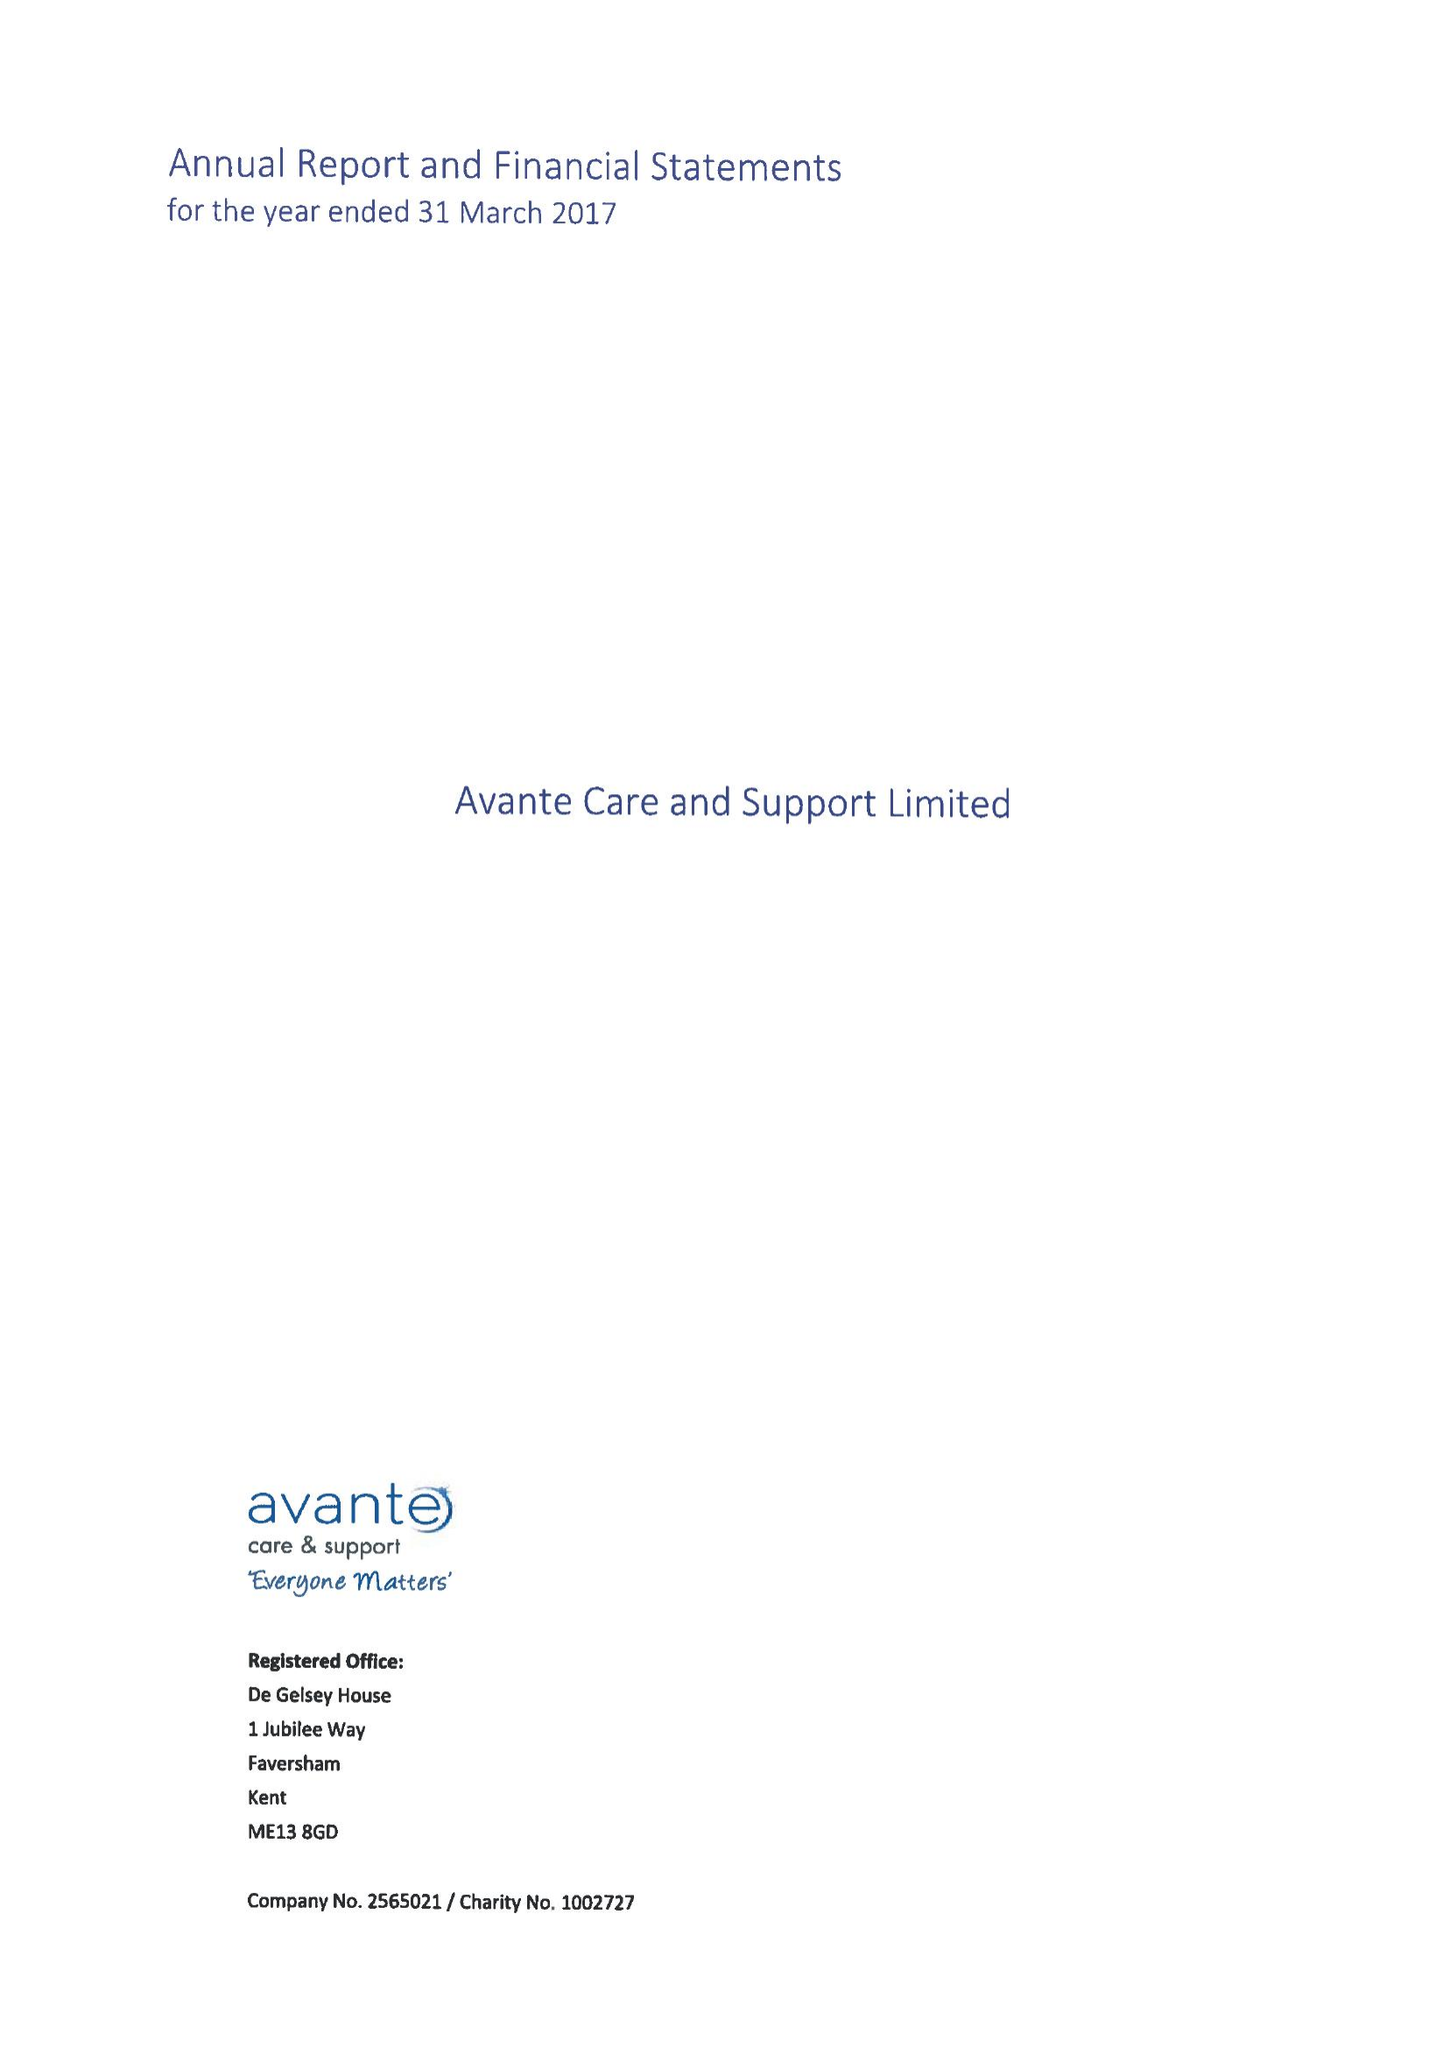What is the value for the income_annually_in_british_pounds?
Answer the question using a single word or phrase. 23887041.00 